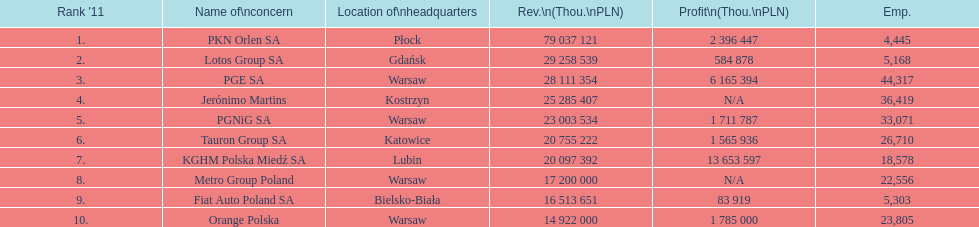How many companies had over $1,000,000 profit? 6. 